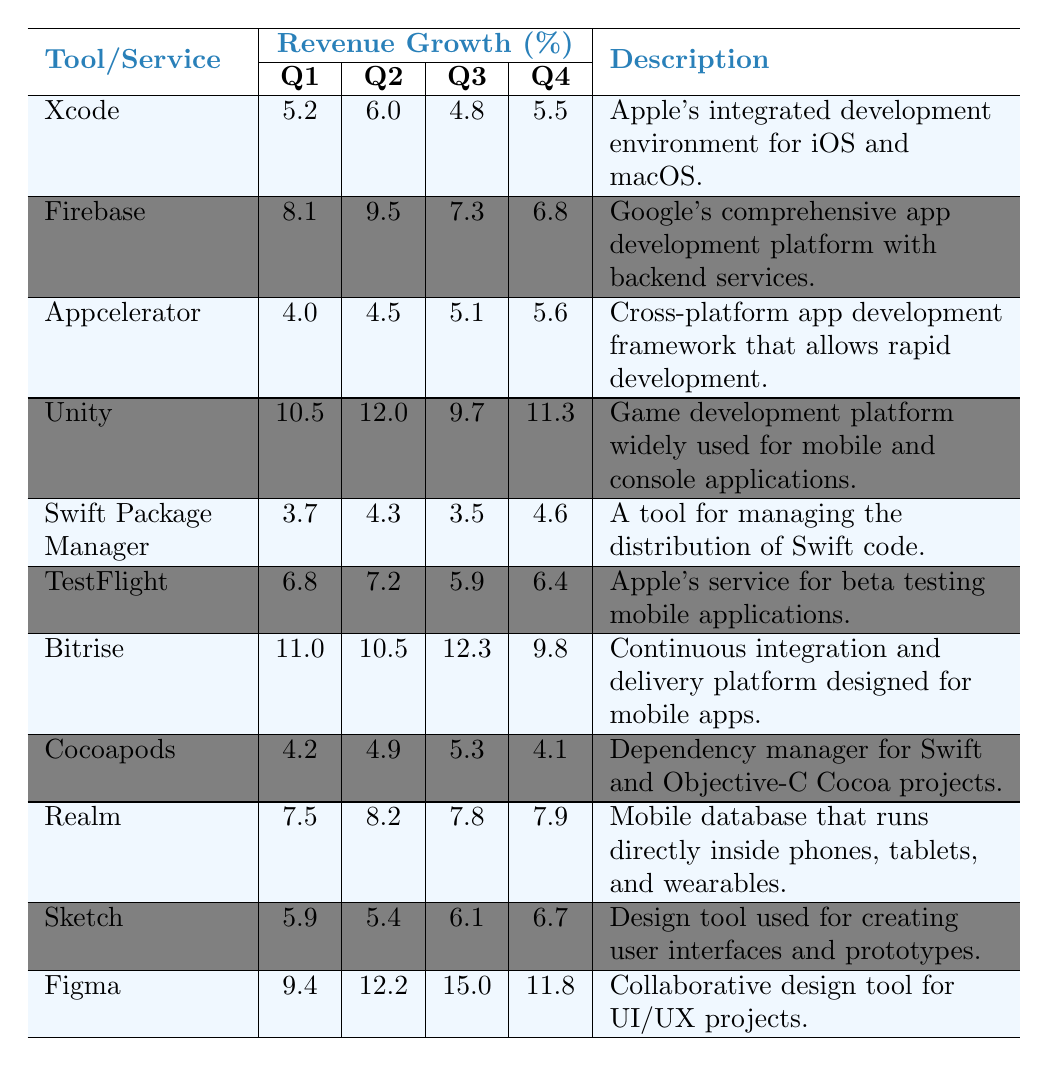What was the highest revenue growth percentage for a tool in Q2? In Q2, the tool with the highest revenue growth percentage is Unity with 12.0%.
Answer: 12.0% Which tool had the lowest revenue growth in Q1? Looking at the Q1 values, Swift Package Manager had the lowest revenue growth at 3.7%.
Answer: 3.7% What is the average revenue growth for Figma over all four quarters? The sum of Figma's quarterly revenue growth is (9.4 + 12.2 + 15.0 + 11.8) = 48.4%. There are 4 quarters, so the average is 48.4 / 4 = 12.1%.
Answer: 12.1% Did any tool have a revenue growth above 10% in all quarters? Analyzing the data, no tool had a revenue growth exceeding 10% in all quarters.
Answer: No Which tool experienced a decline in revenue growth from Q1 to Q4? Comparing the Q1 and Q4 revenue growth, both Appcelerator and Swift Package Manager show decreased values (4.0 to 5.6 and 3.7 to 4.6 respectively) which indicates a decline.
Answer: Yes (Appcelerator and Swift Package Manager) What was the total revenue growth of Bitrise across all quarters? The total for Bitrise is calculated as (11.0 + 10.5 + 12.3 + 9.8) = 43.6%.
Answer: 43.6% Which tool had the most consistent revenue growth across the four quarters? Analyzing the growth patterns, Appcelerator's differences across quarters (1.6%, 0.6%, 0.5%) show a consistent performance compared to others.
Answer: Appcelerator What percentage increase or decrease did Xcode see from Q1 to Q3? The growth decreased from 5.2% in Q1 to 4.8% in Q3, reflecting a difference of (4.8 - 5.2) = -0.4%.
Answer: -0.4% Which tool had the highest revenue growth in Q3? Looking at the Q3 data, Figma recorded the highest revenue growth at 15.0%.
Answer: 15.0% Was the average Q4 revenue growth among all tools greater than 6%? The sum of Q4 growth across all tools is (5.5 + 6.8 + 5.6 + 11.3 + 4.6 + 6.4 + 9.8 + 4.1 + 7.9 + 6.7 + 11.8) = 70.3% and dividing this by 11 gives a value of 70.3 / 11 = 6.4%, which is greater than 6%.
Answer: Yes How does the Q2 revenue growth of Realm compare to that of Xcode? Realm shows a Q2 growth of 8.2%, while Xcode has 6.0%, thus Realm has a higher growth by (8.2 - 6.0) = 2.2%.
Answer: Higher by 2.2% 